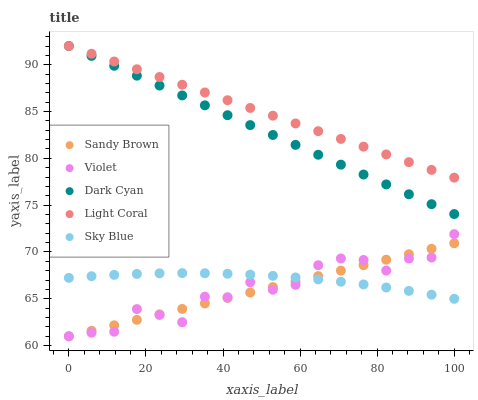Does Sandy Brown have the minimum area under the curve?
Answer yes or no. Yes. Does Light Coral have the maximum area under the curve?
Answer yes or no. Yes. Does Sky Blue have the minimum area under the curve?
Answer yes or no. No. Does Sky Blue have the maximum area under the curve?
Answer yes or no. No. Is Sandy Brown the smoothest?
Answer yes or no. Yes. Is Violet the roughest?
Answer yes or no. Yes. Is Light Coral the smoothest?
Answer yes or no. No. Is Light Coral the roughest?
Answer yes or no. No. Does Sandy Brown have the lowest value?
Answer yes or no. Yes. Does Sky Blue have the lowest value?
Answer yes or no. No. Does Light Coral have the highest value?
Answer yes or no. Yes. Does Sky Blue have the highest value?
Answer yes or no. No. Is Sky Blue less than Dark Cyan?
Answer yes or no. Yes. Is Dark Cyan greater than Sky Blue?
Answer yes or no. Yes. Does Violet intersect Sandy Brown?
Answer yes or no. Yes. Is Violet less than Sandy Brown?
Answer yes or no. No. Is Violet greater than Sandy Brown?
Answer yes or no. No. Does Sky Blue intersect Dark Cyan?
Answer yes or no. No. 